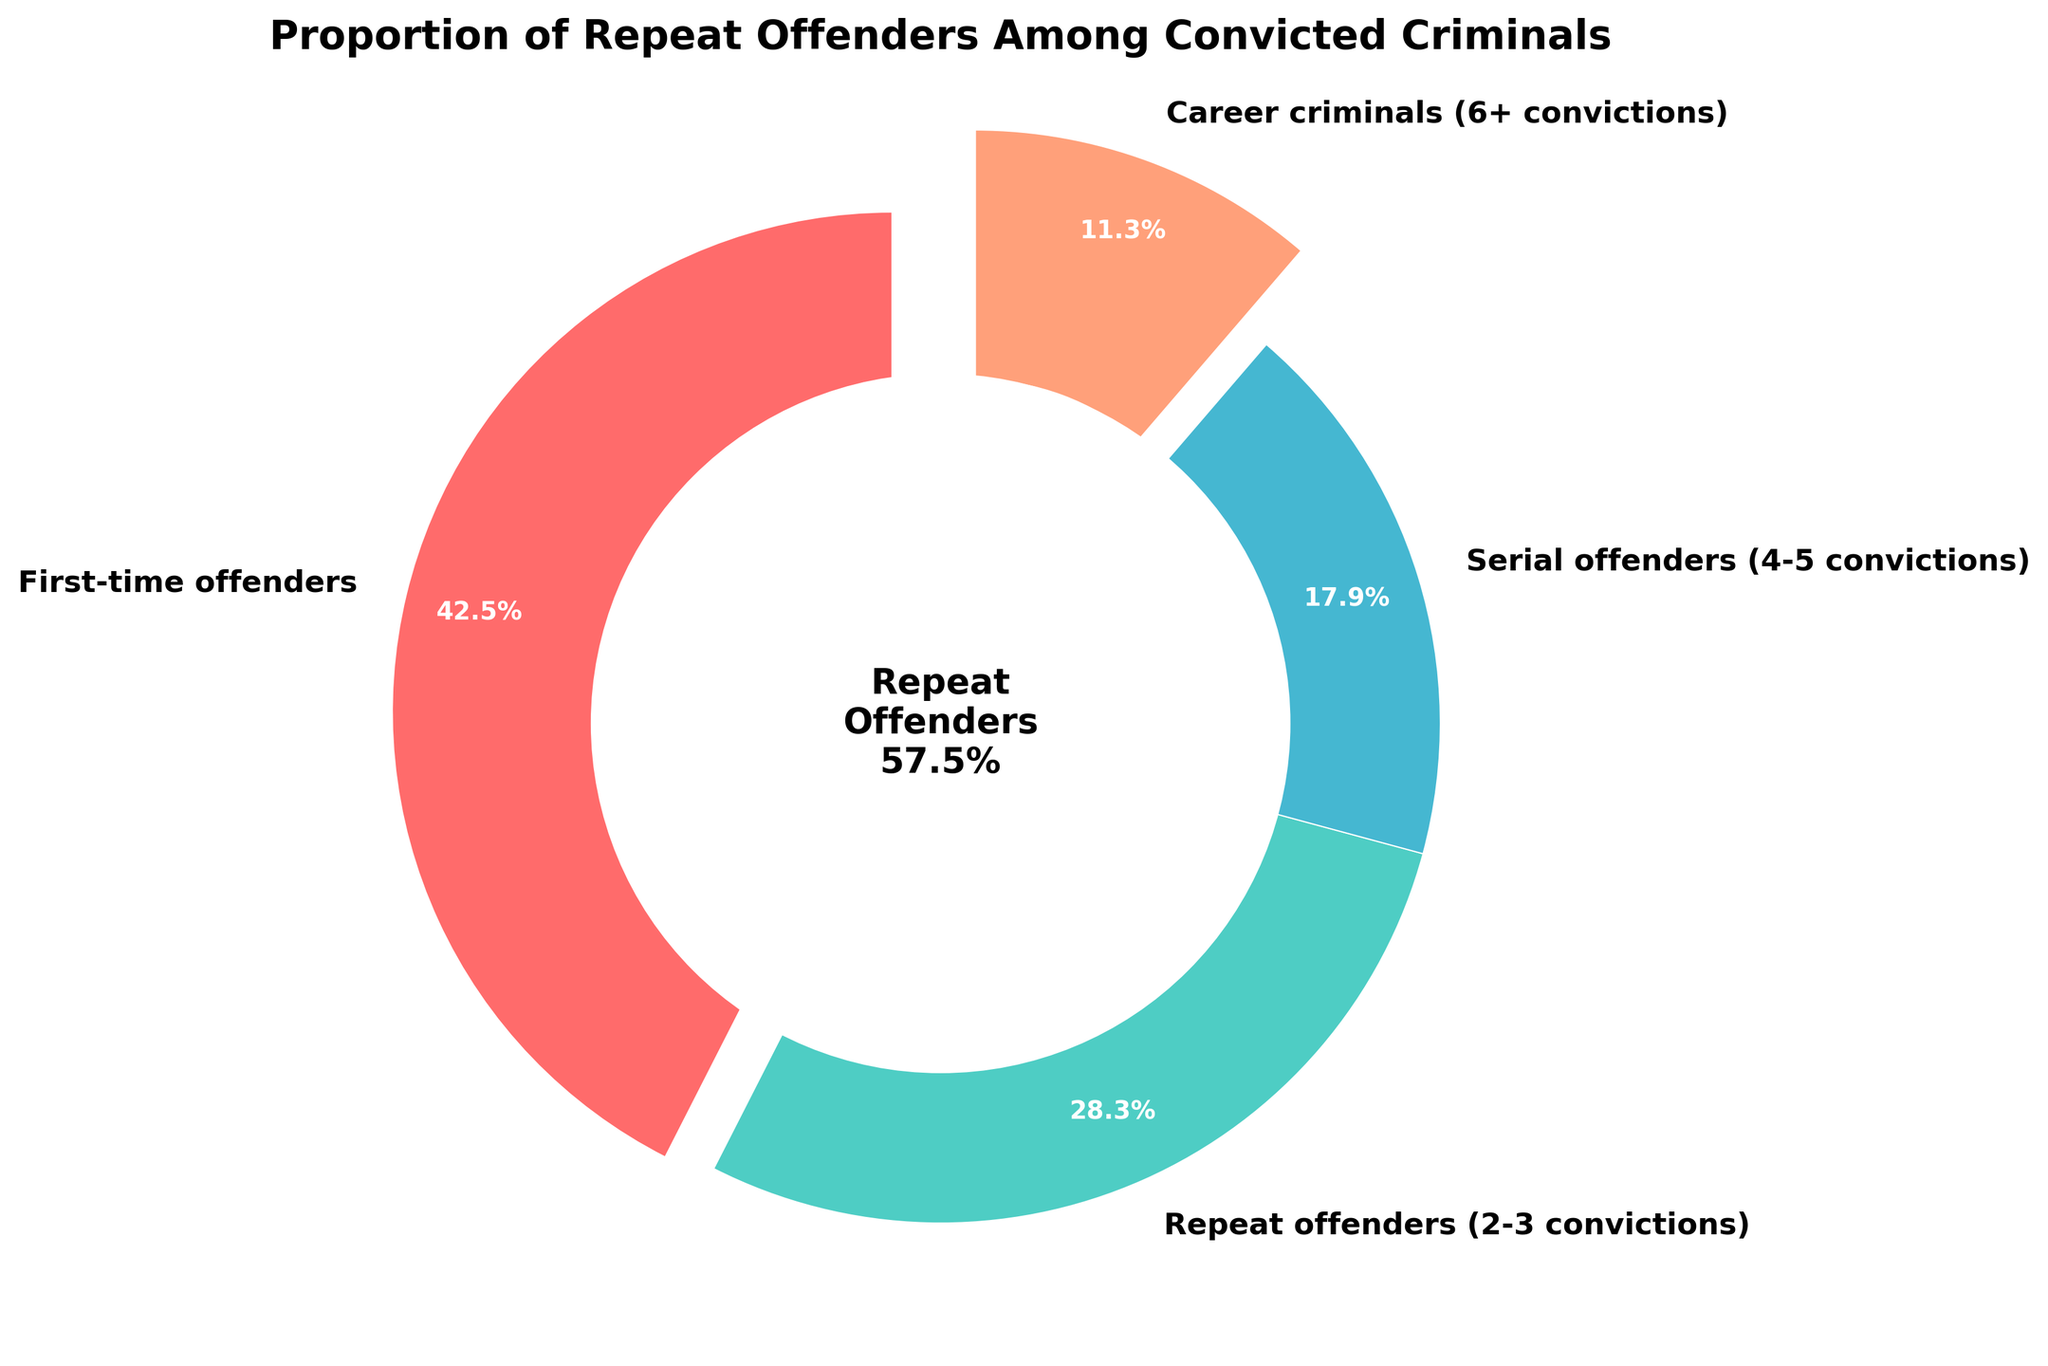What percentage of offenders are first-time offenders? The pie chart shows "First-time offenders" segment labeled with "42.5%".
Answer: 42.5% Which category of offenders has the smallest proportion? The pie chart details that "Career criminals (6+ convictions)" has the smallest slice, labeled as 11.3%.
Answer: Career criminals What percentage of the offenders are serial offenders (4-5 convictions) and career criminals (6+ convictions) combined? Add the percentages of serial offenders (17.9%) and career criminals (11.3%): 17.9% + 11.3% = 29.2%.
Answer: 29.2% How does the proportion of first-time offenders compare to repeat offenders (2-3 convictions)? The chart shows 42.5% for first-time offenders and 28.3% for repeat offenders. Comparing these, 42.5% is greater than 28.3%.
Answer: First-time offenders > Repeat offenders What percentage of offenders are repeat offenders (2-3 convictions) or career criminals (6+ convictions)? Add the percentages: 28.3% (repeat offenders) + 11.3% (career criminals) = 39.6%.
Answer: 39.6% What color represents the serial offenders (4-5 convictions) on the pie chart? The segment labeled as serial offenders (4-5 convictions) is shown in a blue color.
Answer: Blue Among the categories, how many require multiple convictions to be included in the statistics? The chart shows three categories that require multiple convictions: repeat offenders (2-3), serial offenders (4-5), and career criminals (6+).
Answer: 3 What percentage of offenders are NOT repeat offenders (2-3 convictions)? Subtract the repeat offenders' percentage from 100%: 100% - 28.3% = 71.7%.
Answer: 71.7% What is the combined percentage of first-time offenders and serial offenders (4-5 convictions)? Add the percentages: 42.5% (first-time offenders) + 17.9% (serial offenders) = 60.4%.
Answer: 60.4% Does the percentage of career criminals exceed 15%? The pie chart shows career criminals at 11.3%, which is less than 15%.
Answer: No 